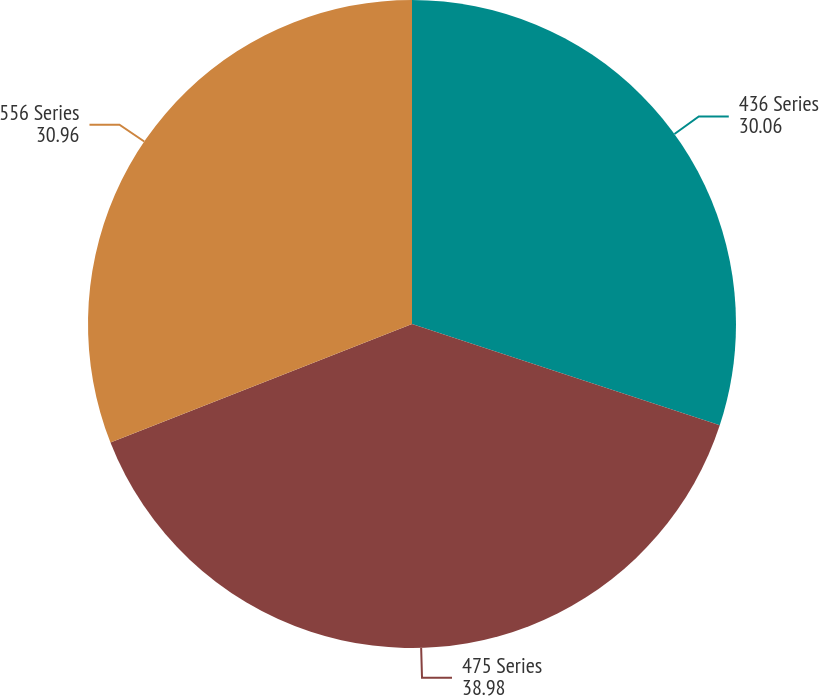<chart> <loc_0><loc_0><loc_500><loc_500><pie_chart><fcel>436 Series<fcel>475 Series<fcel>556 Series<nl><fcel>30.06%<fcel>38.98%<fcel>30.96%<nl></chart> 